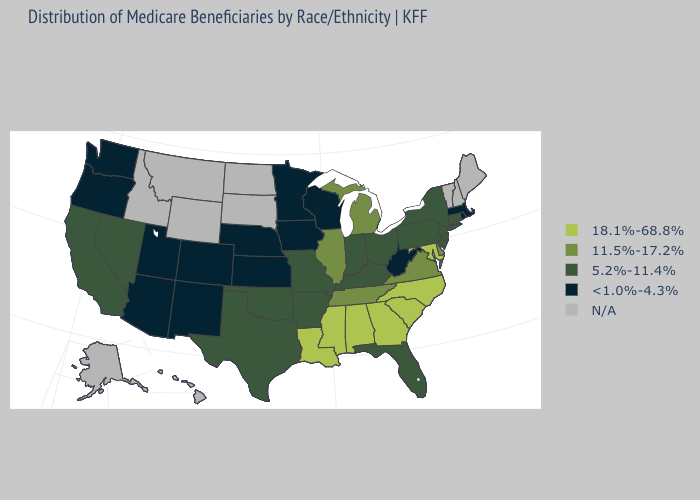What is the value of New Hampshire?
Answer briefly. N/A. Which states have the highest value in the USA?
Quick response, please. Alabama, Georgia, Louisiana, Maryland, Mississippi, North Carolina, South Carolina. Does Iowa have the lowest value in the MidWest?
Be succinct. Yes. Which states have the lowest value in the Northeast?
Answer briefly. Massachusetts, Rhode Island. Name the states that have a value in the range 11.5%-17.2%?
Write a very short answer. Delaware, Illinois, Michigan, Tennessee, Virginia. Among the states that border Connecticut , which have the lowest value?
Give a very brief answer. Massachusetts, Rhode Island. Name the states that have a value in the range N/A?
Quick response, please. Alaska, Hawaii, Idaho, Maine, Montana, New Hampshire, North Dakota, South Dakota, Vermont, Wyoming. Name the states that have a value in the range 5.2%-11.4%?
Be succinct. Arkansas, California, Connecticut, Florida, Indiana, Kentucky, Missouri, Nevada, New Jersey, New York, Ohio, Oklahoma, Pennsylvania, Texas. How many symbols are there in the legend?
Write a very short answer. 5. What is the value of Georgia?
Write a very short answer. 18.1%-68.8%. Name the states that have a value in the range <1.0%-4.3%?
Answer briefly. Arizona, Colorado, Iowa, Kansas, Massachusetts, Minnesota, Nebraska, New Mexico, Oregon, Rhode Island, Utah, Washington, West Virginia, Wisconsin. Does Virginia have the highest value in the South?
Short answer required. No. What is the highest value in the USA?
Answer briefly. 18.1%-68.8%. 